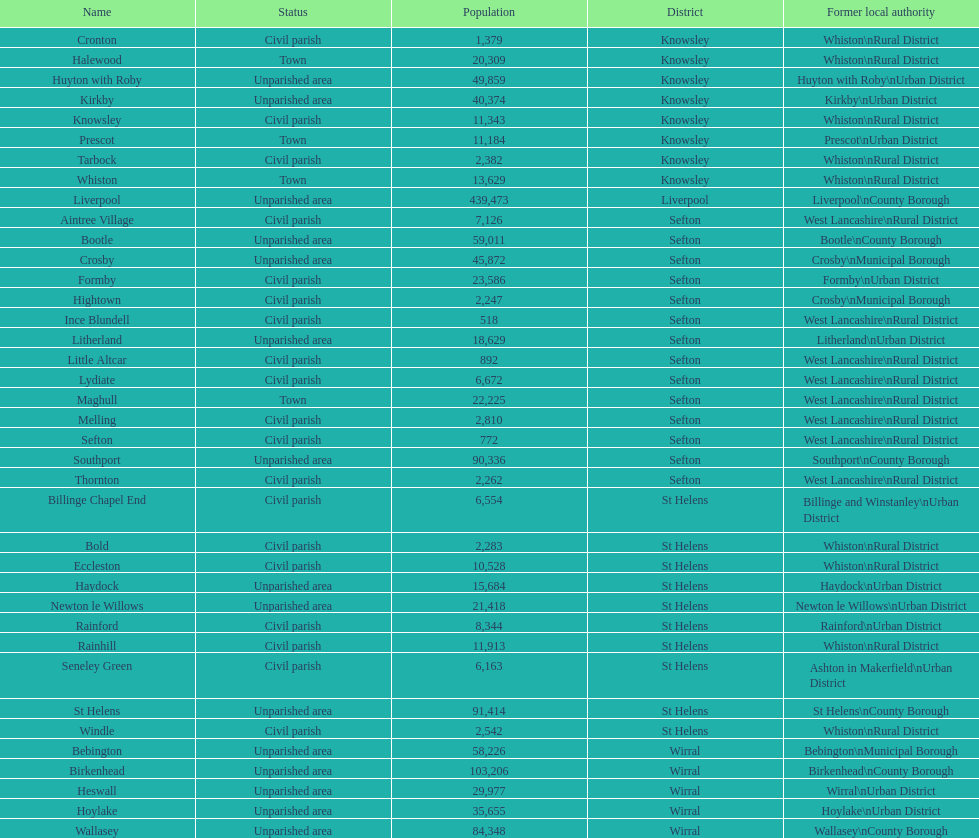How many civil parishes possess population numbers of a minimum of 10,000? 4. 